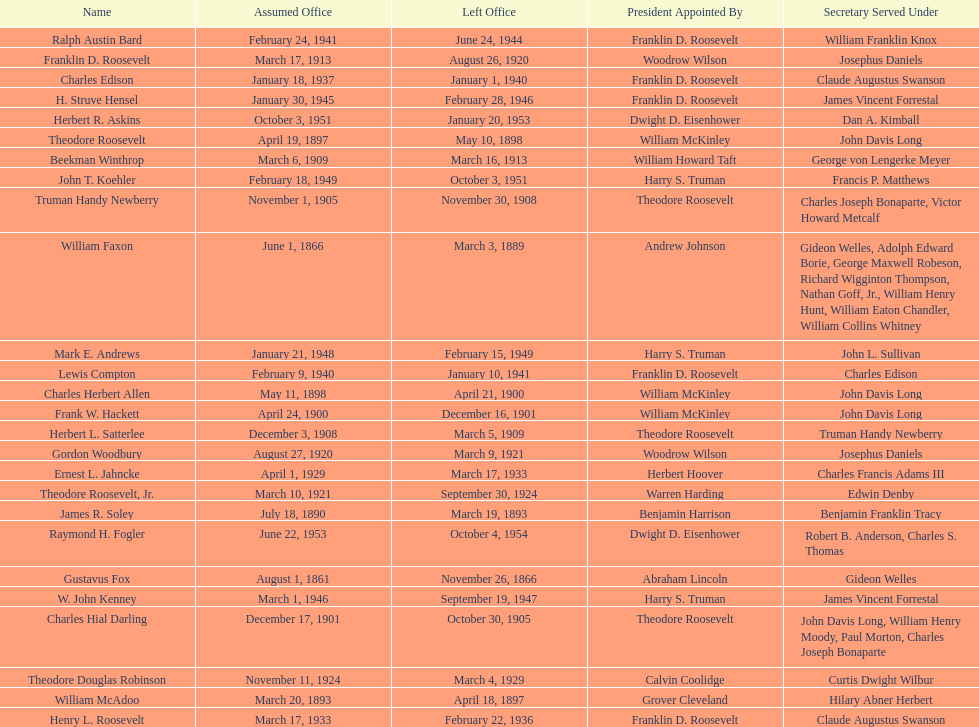When did raymond h. fogler leave the office of assistant secretary of the navy? October 4, 1954. 